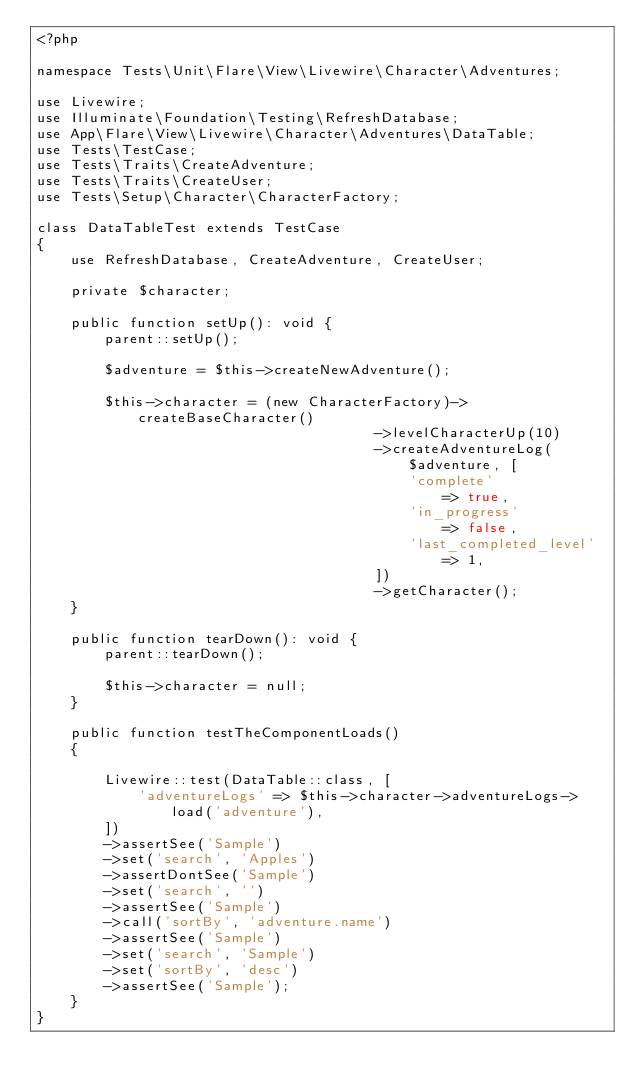<code> <loc_0><loc_0><loc_500><loc_500><_PHP_><?php

namespace Tests\Unit\Flare\View\Livewire\Character\Adventures;

use Livewire;
use Illuminate\Foundation\Testing\RefreshDatabase;
use App\Flare\View\Livewire\Character\Adventures\DataTable;
use Tests\TestCase;
use Tests\Traits\CreateAdventure;
use Tests\Traits\CreateUser;
use Tests\Setup\Character\CharacterFactory;

class DataTableTest extends TestCase
{
    use RefreshDatabase, CreateAdventure, CreateUser;

    private $character;

    public function setUp(): void {
        parent::setUp();

        $adventure = $this->createNewAdventure();

        $this->character = (new CharacterFactory)->createBaseCharacter()
                                        ->levelCharacterUp(10)
                                        ->createAdventureLog($adventure, [
                                            'complete'             => true,
                                            'in_progress'          => false,
                                            'last_completed_level' => 1,
                                        ])
                                        ->getCharacter();
    }

    public function tearDown(): void {
        parent::tearDown();

        $this->character = null;
    }

    public function testTheComponentLoads()
    {
        
        Livewire::test(DataTable::class, [
            'adventureLogs' => $this->character->adventureLogs->load('adventure'),
        ])
        ->assertSee('Sample')
        ->set('search', 'Apples')
        ->assertDontSee('Sample')
        ->set('search', '')
        ->assertSee('Sample')
        ->call('sortBy', 'adventure.name')
        ->assertSee('Sample')
        ->set('search', 'Sample')
        ->set('sortBy', 'desc')
        ->assertSee('Sample');
    }
}
</code> 